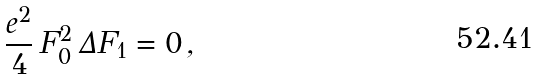<formula> <loc_0><loc_0><loc_500><loc_500>\frac { e ^ { 2 } } { 4 } \, F _ { 0 } ^ { 2 } \, \Delta F _ { 1 } = 0 \, ,</formula> 